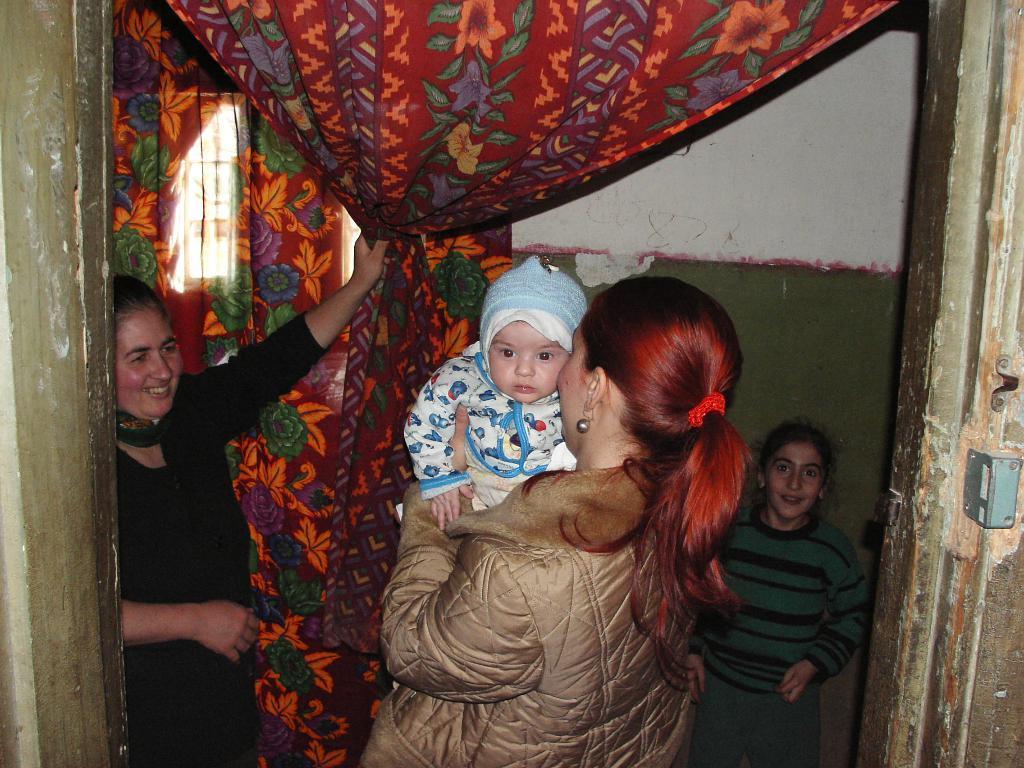Please provide a concise description of this image. In this image, we can see people wearing coats and there is a lady holding a baby and in the background, there are curtains and there is a wall and a window. 